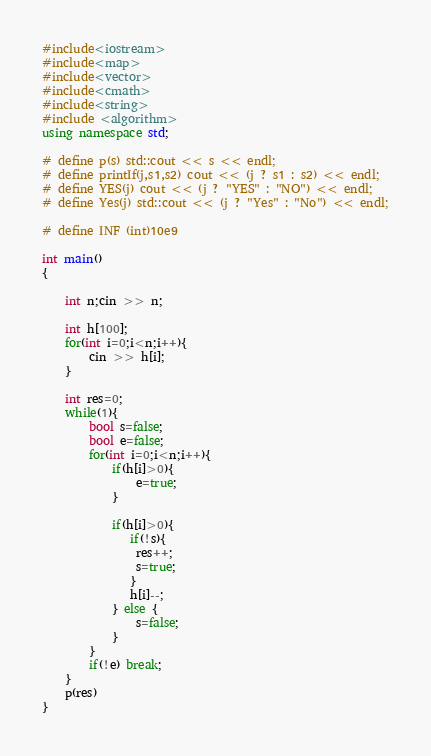Convert code to text. <code><loc_0><loc_0><loc_500><loc_500><_C++_>#include<iostream>
#include<map>
#include<vector>
#include<cmath>
#include<string>
#include <algorithm> 
using namespace std;

# define p(s) std::cout << s << endl;
# define printIf(j,s1,s2) cout << (j ? s1 : s2) << endl;
# define YES(j) cout << (j ? "YES" : "NO") << endl;
# define Yes(j) std::cout << (j ? "Yes" : "No") << endl;

# define INF (int)10e9

int main()
{

    int n;cin >> n;

    int h[100];
    for(int i=0;i<n;i++){
        cin >> h[i];
    }

    int res=0;
    while(1){
        bool s=false;
        bool e=false;
        for(int i=0;i<n;i++){
            if(h[i]>0){
                e=true;
            }

            if(h[i]>0){
               if(!s){
                res++;
                s=true;
               }
               h[i]--;
            } else {
                s=false;
            }
        }
        if(!e) break;
    }
    p(res)
}</code> 